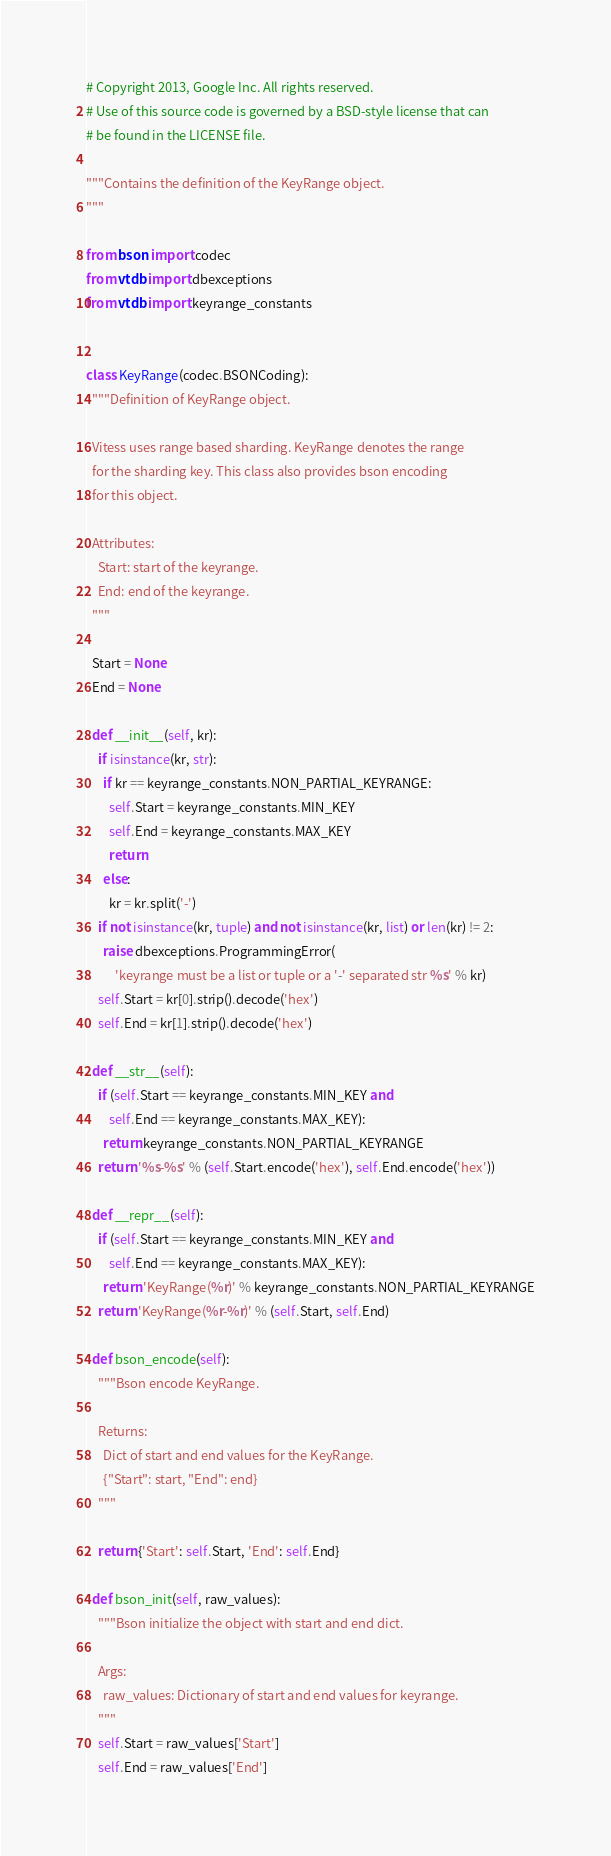Convert code to text. <code><loc_0><loc_0><loc_500><loc_500><_Python_># Copyright 2013, Google Inc. All rights reserved.
# Use of this source code is governed by a BSD-style license that can
# be found in the LICENSE file.

"""Contains the definition of the KeyRange object.
"""

from bson import codec
from vtdb import dbexceptions
from vtdb import keyrange_constants


class KeyRange(codec.BSONCoding):
  """Definition of KeyRange object.

  Vitess uses range based sharding. KeyRange denotes the range
  for the sharding key. This class also provides bson encoding
  for this object.

  Attributes:
    Start: start of the keyrange.
    End: end of the keyrange.
  """

  Start = None
  End = None

  def __init__(self, kr):
    if isinstance(kr, str):
      if kr == keyrange_constants.NON_PARTIAL_KEYRANGE:
        self.Start = keyrange_constants.MIN_KEY
        self.End = keyrange_constants.MAX_KEY
        return
      else:
        kr = kr.split('-')
    if not isinstance(kr, tuple) and not isinstance(kr, list) or len(kr) != 2:
      raise dbexceptions.ProgrammingError(
          'keyrange must be a list or tuple or a '-' separated str %s' % kr)
    self.Start = kr[0].strip().decode('hex')
    self.End = kr[1].strip().decode('hex')

  def __str__(self):
    if (self.Start == keyrange_constants.MIN_KEY and
        self.End == keyrange_constants.MAX_KEY):
      return keyrange_constants.NON_PARTIAL_KEYRANGE
    return '%s-%s' % (self.Start.encode('hex'), self.End.encode('hex'))

  def __repr__(self):
    if (self.Start == keyrange_constants.MIN_KEY and
        self.End == keyrange_constants.MAX_KEY):
      return 'KeyRange(%r)' % keyrange_constants.NON_PARTIAL_KEYRANGE
    return 'KeyRange(%r-%r)' % (self.Start, self.End)

  def bson_encode(self):
    """Bson encode KeyRange.

    Returns:
      Dict of start and end values for the KeyRange.
      {"Start": start, "End": end}
    """

    return {'Start': self.Start, 'End': self.End}

  def bson_init(self, raw_values):
    """Bson initialize the object with start and end dict.

    Args:
      raw_values: Dictionary of start and end values for keyrange.
    """
    self.Start = raw_values['Start']
    self.End = raw_values['End']
</code> 